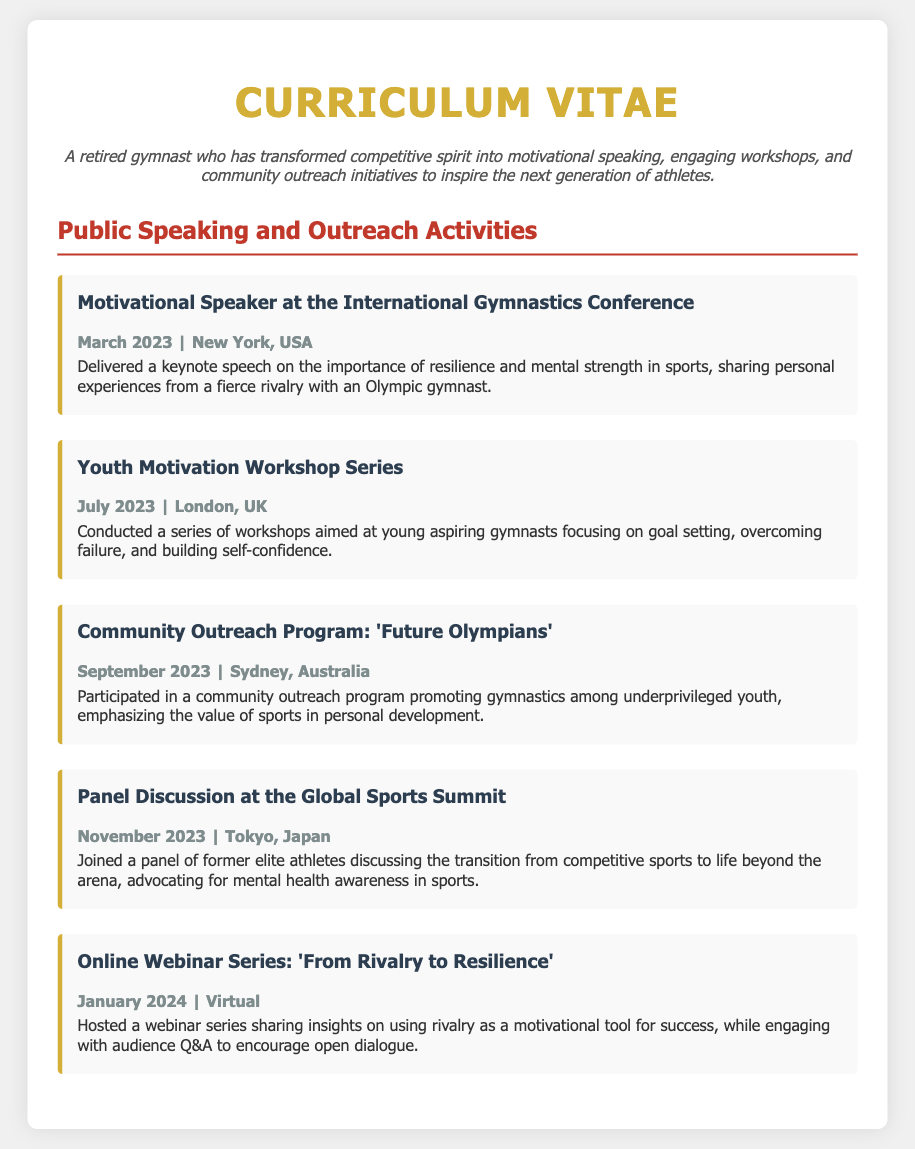What was the date of the engagement in New York? The date is specified in the document under the engagement at the International Gymnastics Conference.
Answer: March 2023 What is the title of the workshop series conducted in London? The title is found in the description of the workshop held in July 2023.
Answer: Youth Motivation Workshop Series Which community outreach program took place in Sydney? The program name is mentioned in the description of the engagement related to underprivileged youth.
Answer: Future Olympians What was the main topic discussed at the panel in Tokyo? The main topic is indicated in the description of the panel discussion at the Global Sports Summit.
Answer: Mental health awareness in sports How many engagements are listed under Public Speaking and Outreach Activities? The number is determined by counting the engagements detailed in that section.
Answer: Five 